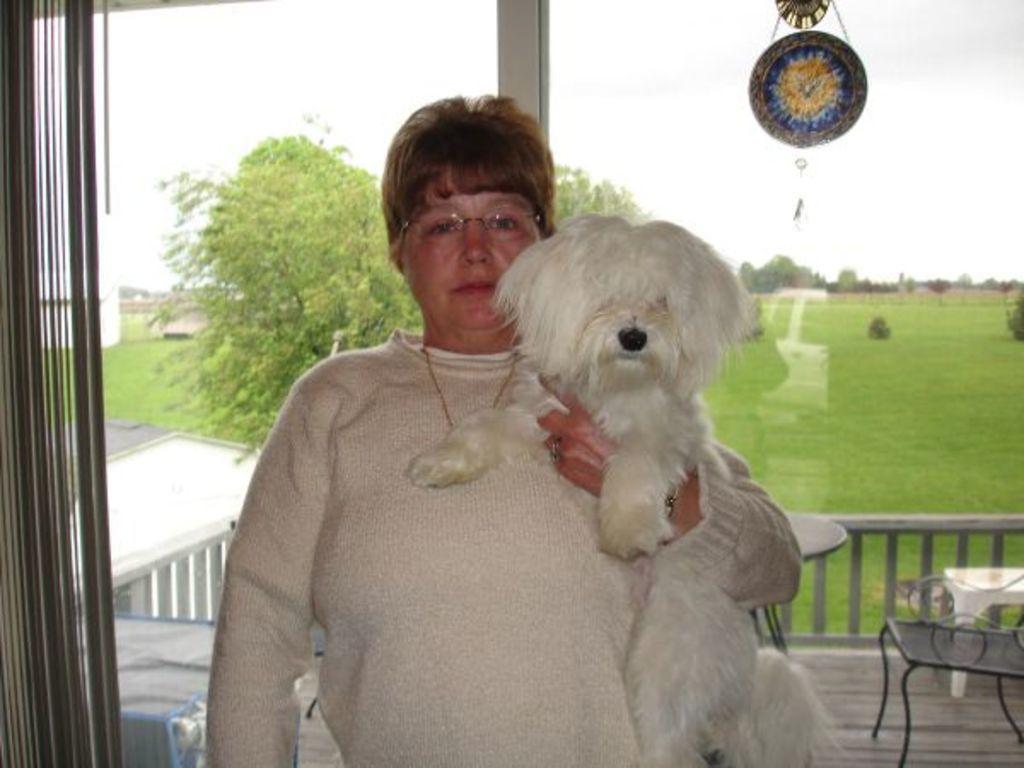Who is present in the image? There is a woman in the image. What is the woman holding? The woman is holding a dog. What can be seen in the background of the image? There is a table, a chair, trees, and grass visible in the background of the image. What type of plastic is covering the pies on the table in the image? There are no pies or plastic covering present in the image. Can you describe the frog sitting on the chair in the background of the image? There is no frog present in the image; it only features a woman holding a dog, a table, a chair, trees, and grass in the background. 